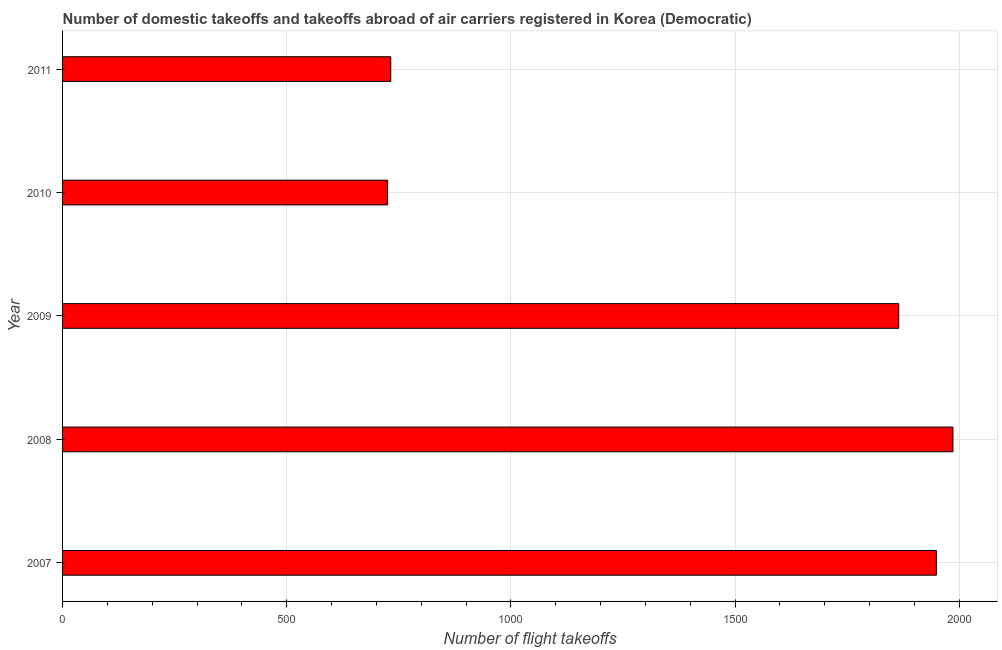What is the title of the graph?
Make the answer very short. Number of domestic takeoffs and takeoffs abroad of air carriers registered in Korea (Democratic). What is the label or title of the X-axis?
Offer a terse response. Number of flight takeoffs. What is the number of flight takeoffs in 2007?
Offer a very short reply. 1949. Across all years, what is the maximum number of flight takeoffs?
Give a very brief answer. 1986. Across all years, what is the minimum number of flight takeoffs?
Provide a short and direct response. 725. In which year was the number of flight takeoffs maximum?
Your response must be concise. 2008. What is the sum of the number of flight takeoffs?
Give a very brief answer. 7257. What is the difference between the number of flight takeoffs in 2008 and 2010?
Offer a terse response. 1261. What is the average number of flight takeoffs per year?
Your answer should be compact. 1451.4. What is the median number of flight takeoffs?
Your response must be concise. 1865. Do a majority of the years between 2009 and 2011 (inclusive) have number of flight takeoffs greater than 100 ?
Your response must be concise. Yes. What is the ratio of the number of flight takeoffs in 2010 to that in 2011?
Keep it short and to the point. 0.99. What is the difference between the highest and the second highest number of flight takeoffs?
Make the answer very short. 37. What is the difference between the highest and the lowest number of flight takeoffs?
Make the answer very short. 1261. Are the values on the major ticks of X-axis written in scientific E-notation?
Your answer should be very brief. No. What is the Number of flight takeoffs of 2007?
Ensure brevity in your answer.  1949. What is the Number of flight takeoffs of 2008?
Offer a terse response. 1986. What is the Number of flight takeoffs of 2009?
Your response must be concise. 1865. What is the Number of flight takeoffs in 2010?
Keep it short and to the point. 725. What is the Number of flight takeoffs in 2011?
Provide a succinct answer. 732. What is the difference between the Number of flight takeoffs in 2007 and 2008?
Offer a terse response. -37. What is the difference between the Number of flight takeoffs in 2007 and 2010?
Offer a terse response. 1224. What is the difference between the Number of flight takeoffs in 2007 and 2011?
Ensure brevity in your answer.  1217. What is the difference between the Number of flight takeoffs in 2008 and 2009?
Keep it short and to the point. 121. What is the difference between the Number of flight takeoffs in 2008 and 2010?
Your answer should be compact. 1261. What is the difference between the Number of flight takeoffs in 2008 and 2011?
Provide a short and direct response. 1254. What is the difference between the Number of flight takeoffs in 2009 and 2010?
Keep it short and to the point. 1140. What is the difference between the Number of flight takeoffs in 2009 and 2011?
Your answer should be very brief. 1133. What is the difference between the Number of flight takeoffs in 2010 and 2011?
Make the answer very short. -7. What is the ratio of the Number of flight takeoffs in 2007 to that in 2008?
Your answer should be very brief. 0.98. What is the ratio of the Number of flight takeoffs in 2007 to that in 2009?
Give a very brief answer. 1.04. What is the ratio of the Number of flight takeoffs in 2007 to that in 2010?
Make the answer very short. 2.69. What is the ratio of the Number of flight takeoffs in 2007 to that in 2011?
Offer a very short reply. 2.66. What is the ratio of the Number of flight takeoffs in 2008 to that in 2009?
Make the answer very short. 1.06. What is the ratio of the Number of flight takeoffs in 2008 to that in 2010?
Provide a succinct answer. 2.74. What is the ratio of the Number of flight takeoffs in 2008 to that in 2011?
Provide a short and direct response. 2.71. What is the ratio of the Number of flight takeoffs in 2009 to that in 2010?
Offer a terse response. 2.57. What is the ratio of the Number of flight takeoffs in 2009 to that in 2011?
Your response must be concise. 2.55. What is the ratio of the Number of flight takeoffs in 2010 to that in 2011?
Your response must be concise. 0.99. 